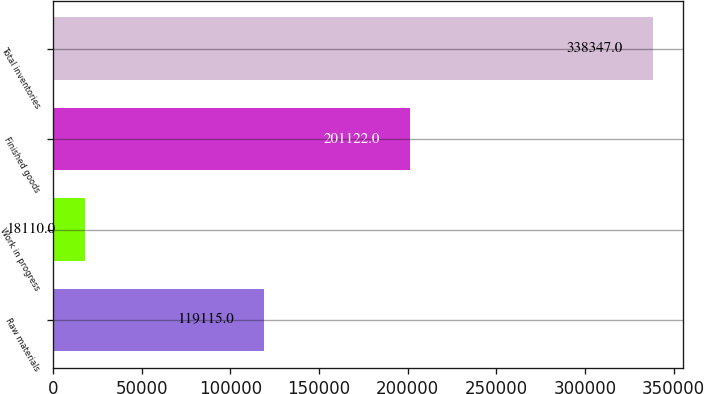Convert chart. <chart><loc_0><loc_0><loc_500><loc_500><bar_chart><fcel>Raw materials<fcel>Work in progress<fcel>Finished goods<fcel>Total inventories<nl><fcel>119115<fcel>18110<fcel>201122<fcel>338347<nl></chart> 